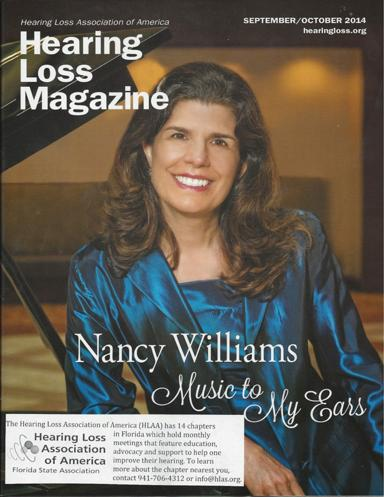Can you describe the main theme of this magazine issue? The main theme of this issue seems to revolve around personal stories and successes in managing hearing loss, as can be seen from Nancy Williams' feature story, illustrating the positive impact of music on her life despite her hearing challenges. 